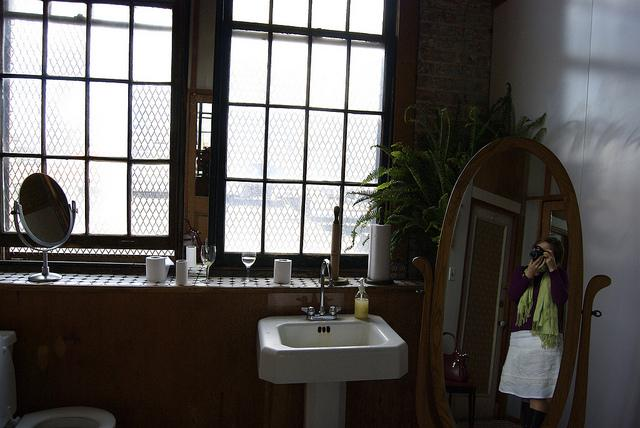Which feature of the camera poses harm to the person taking a photograph of a mirror? Please explain your reasoning. flash. The feature is flash. 